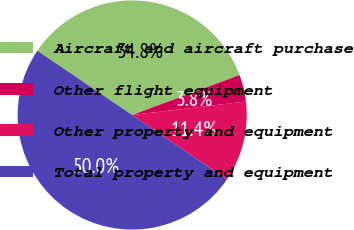Convert chart. <chart><loc_0><loc_0><loc_500><loc_500><pie_chart><fcel>Aircraft and aircraft purchase<fcel>Other flight equipment<fcel>Other property and equipment<fcel>Total property and equipment<nl><fcel>34.85%<fcel>3.79%<fcel>11.36%<fcel>50.0%<nl></chart> 